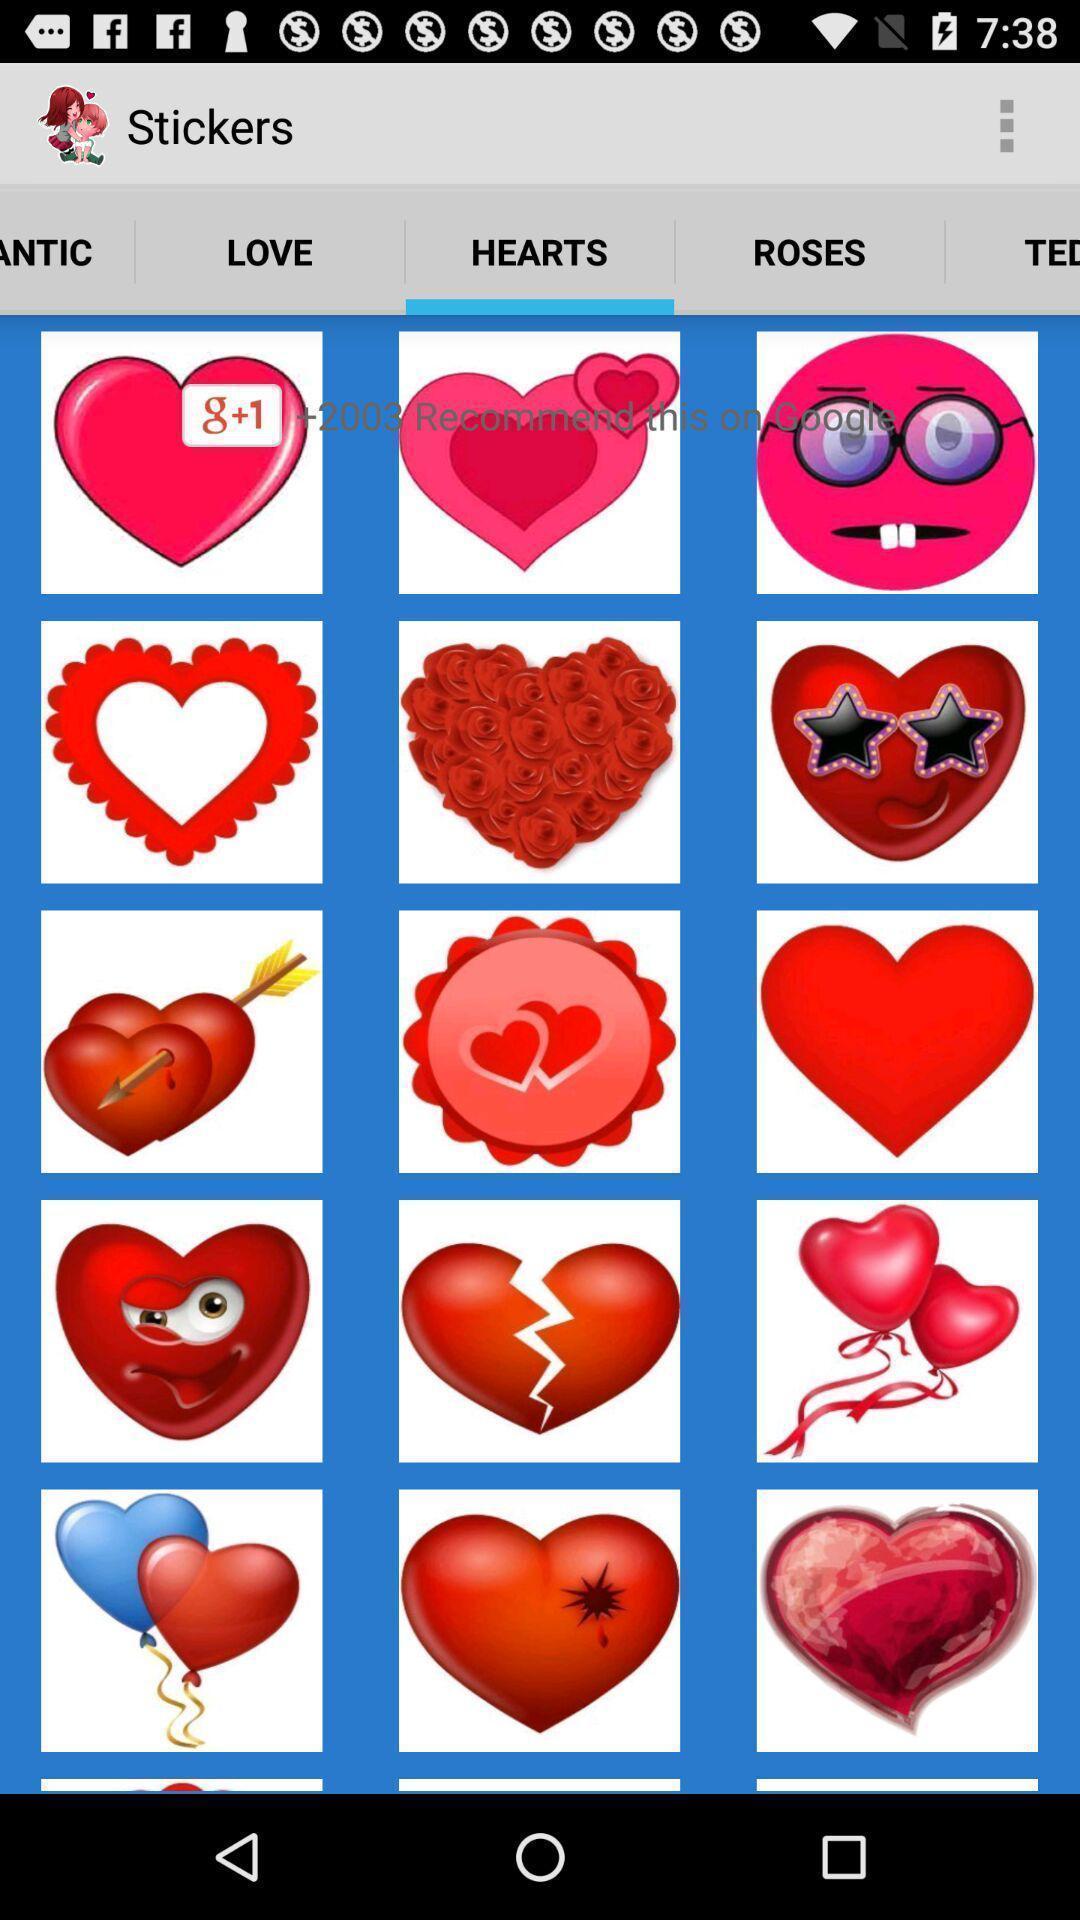What can you discern from this picture? Page showing different options in a images related app. 